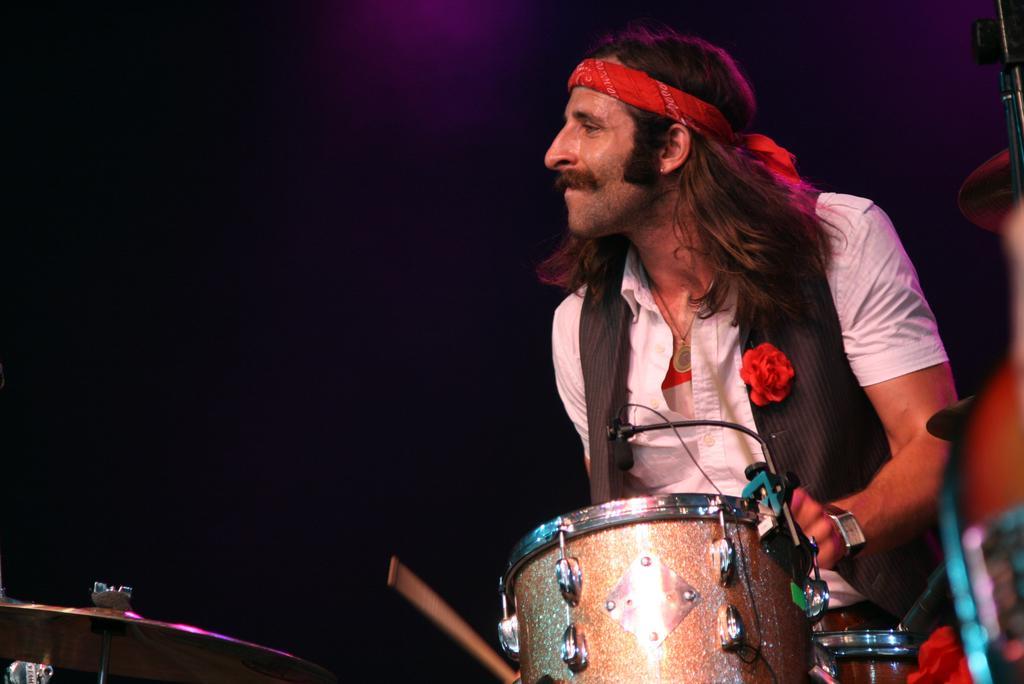Can you describe this image briefly? In this picture we can see a man with long hair playing drums and looking at someone. 